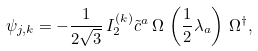<formula> <loc_0><loc_0><loc_500><loc_500>\psi _ { j , k } = - \frac { 1 } { 2 \sqrt { 3 } } \, I _ { 2 } ^ { ( k ) } \tilde { c } ^ { a } \, \Omega \, \left ( \frac { 1 } { 2 } \lambda _ { a } \right ) \, \Omega ^ { \dagger } ,</formula> 